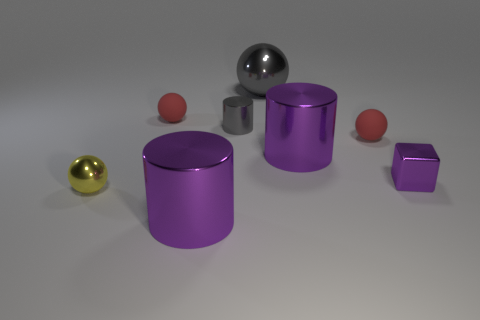Can you tell me the colors of the objects in the image? Certainly! In the image, there are objects in three distinct colors. There is a gold sphere, a pair of purple cylinders, and three objects in different shades of gray, which includes a large sphere, a small sphere, and a cube.  Are there any reflective surfaces visible? Yes, indeed. The spheres and the cylinders in the image show reflective properties, with visible highlights and reflections on their surfaces, indicating they are made of a material like metal or polished plastic. 